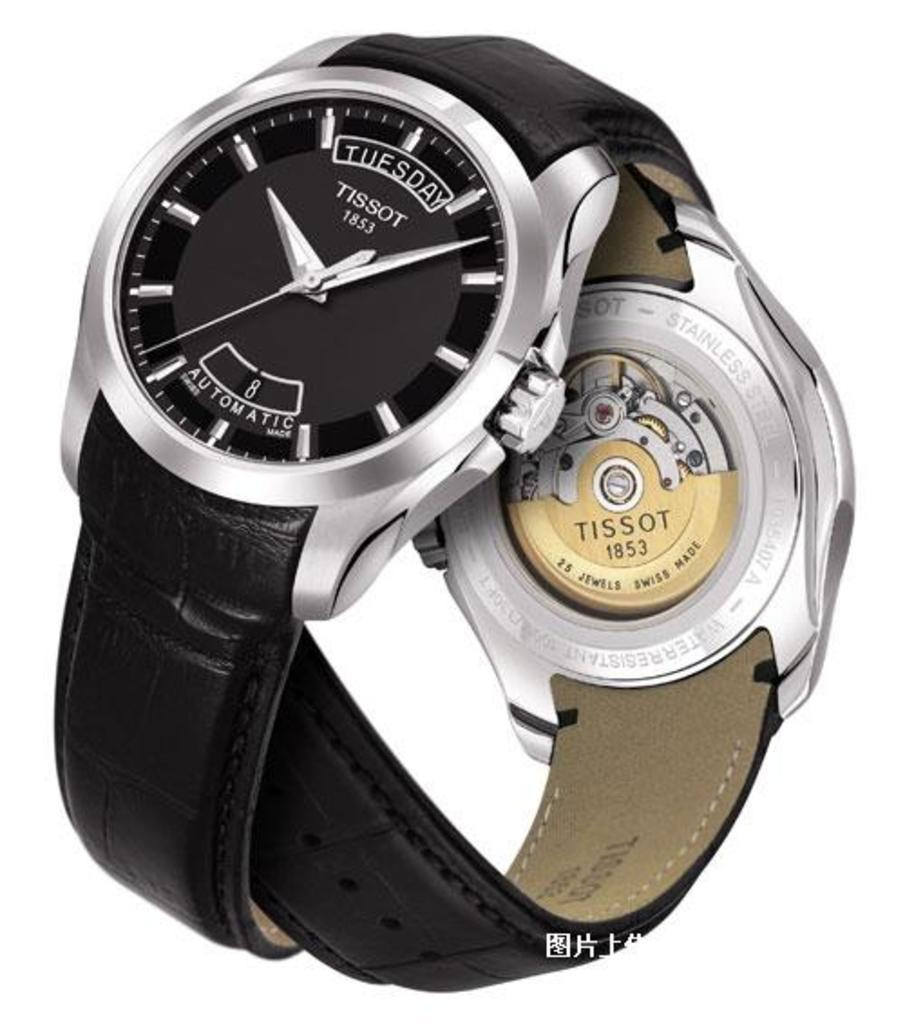<image>
Offer a succinct explanation of the picture presented. An automatic Tissot 1852 watch showing both the outside and inside of the band. 